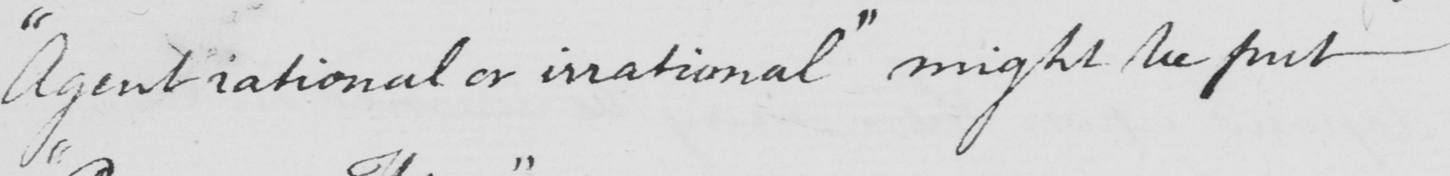Can you tell me what this handwritten text says? " Agent rational or irrational "  might be put 